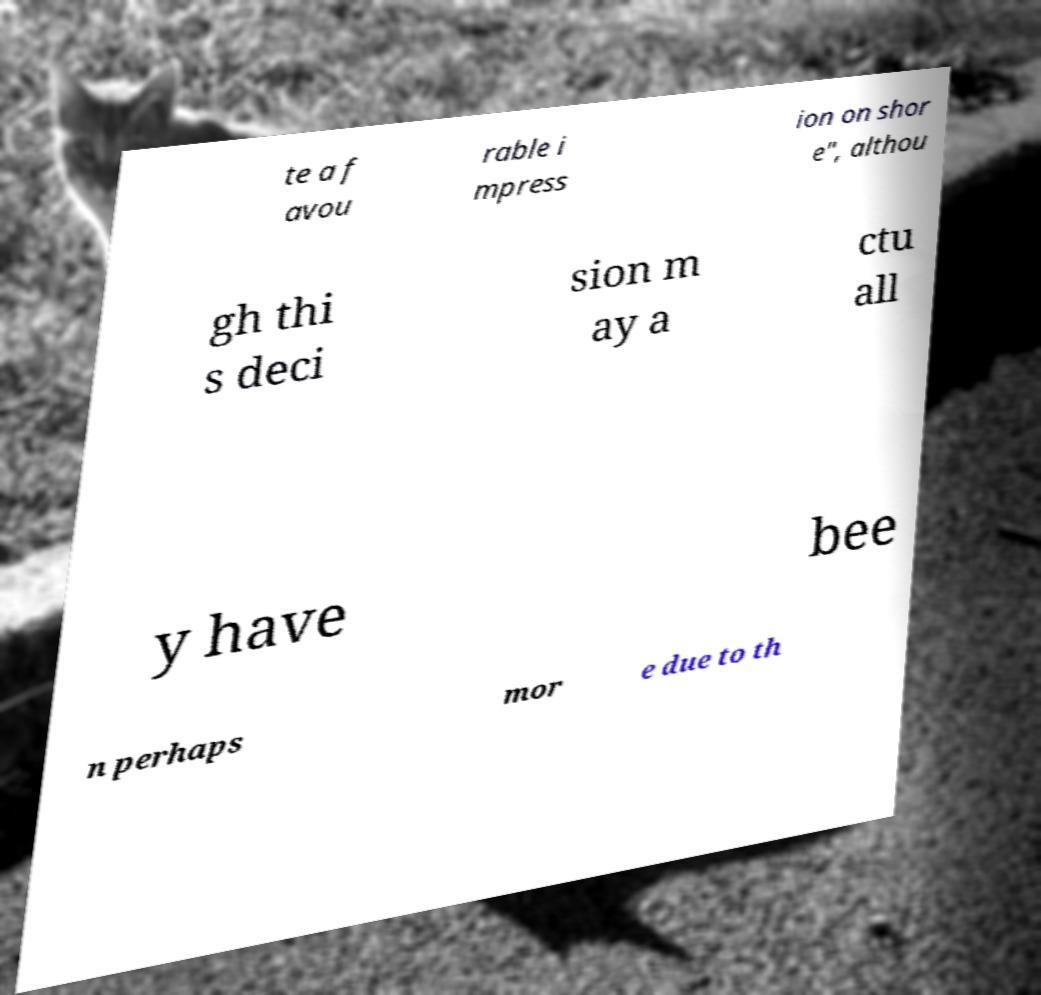For documentation purposes, I need the text within this image transcribed. Could you provide that? te a f avou rable i mpress ion on shor e", althou gh thi s deci sion m ay a ctu all y have bee n perhaps mor e due to th 